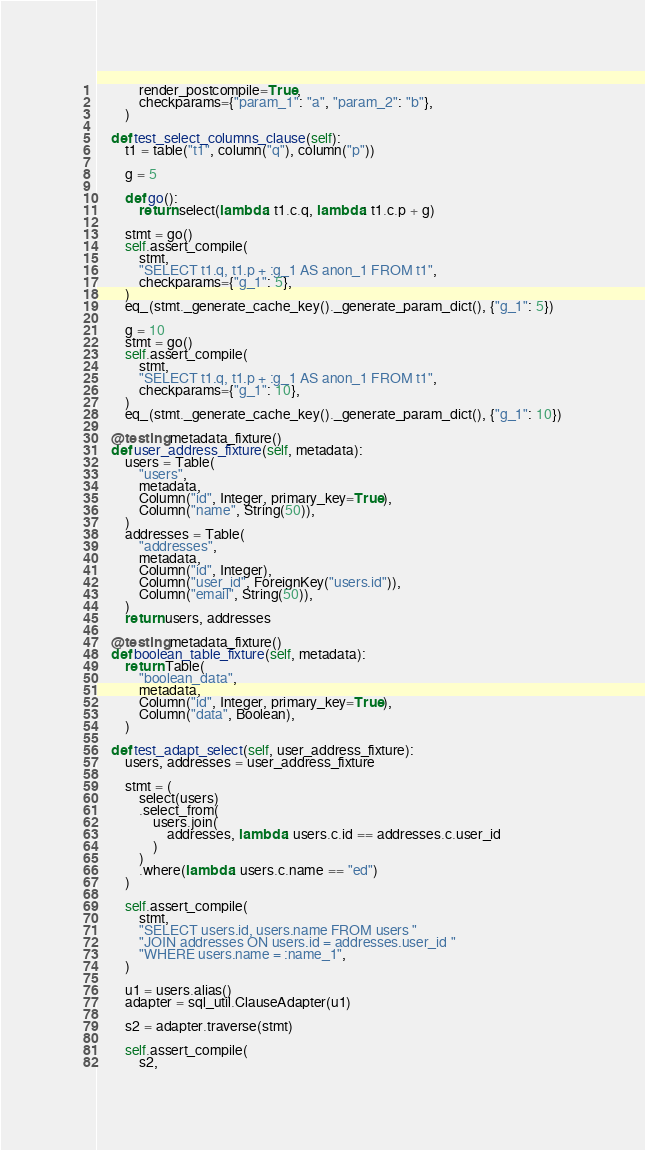Convert code to text. <code><loc_0><loc_0><loc_500><loc_500><_Python_>            render_postcompile=True,
            checkparams={"param_1": "a", "param_2": "b"},
        )

    def test_select_columns_clause(self):
        t1 = table("t1", column("q"), column("p"))

        g = 5

        def go():
            return select(lambda: t1.c.q, lambda: t1.c.p + g)

        stmt = go()
        self.assert_compile(
            stmt,
            "SELECT t1.q, t1.p + :g_1 AS anon_1 FROM t1",
            checkparams={"g_1": 5},
        )
        eq_(stmt._generate_cache_key()._generate_param_dict(), {"g_1": 5})

        g = 10
        stmt = go()
        self.assert_compile(
            stmt,
            "SELECT t1.q, t1.p + :g_1 AS anon_1 FROM t1",
            checkparams={"g_1": 10},
        )
        eq_(stmt._generate_cache_key()._generate_param_dict(), {"g_1": 10})

    @testing.metadata_fixture()
    def user_address_fixture(self, metadata):
        users = Table(
            "users",
            metadata,
            Column("id", Integer, primary_key=True),
            Column("name", String(50)),
        )
        addresses = Table(
            "addresses",
            metadata,
            Column("id", Integer),
            Column("user_id", ForeignKey("users.id")),
            Column("email", String(50)),
        )
        return users, addresses

    @testing.metadata_fixture()
    def boolean_table_fixture(self, metadata):
        return Table(
            "boolean_data",
            metadata,
            Column("id", Integer, primary_key=True),
            Column("data", Boolean),
        )

    def test_adapt_select(self, user_address_fixture):
        users, addresses = user_address_fixture

        stmt = (
            select(users)
            .select_from(
                users.join(
                    addresses, lambda: users.c.id == addresses.c.user_id
                )
            )
            .where(lambda: users.c.name == "ed")
        )

        self.assert_compile(
            stmt,
            "SELECT users.id, users.name FROM users "
            "JOIN addresses ON users.id = addresses.user_id "
            "WHERE users.name = :name_1",
        )

        u1 = users.alias()
        adapter = sql_util.ClauseAdapter(u1)

        s2 = adapter.traverse(stmt)

        self.assert_compile(
            s2,</code> 